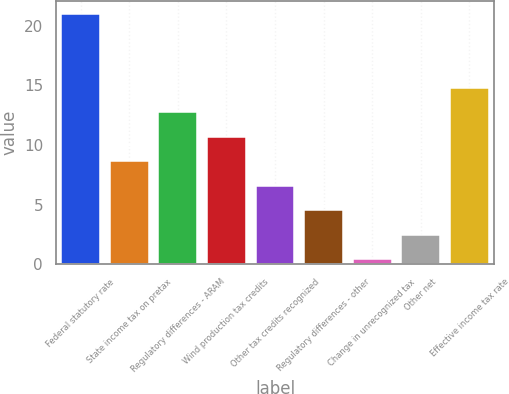<chart> <loc_0><loc_0><loc_500><loc_500><bar_chart><fcel>Federal statutory rate<fcel>State income tax on pretax<fcel>Regulatory differences - ARAM<fcel>Wind production tax credits<fcel>Other tax credits recognized<fcel>Regulatory differences - other<fcel>Change in unrecognized tax<fcel>Other net<fcel>Effective income tax rate<nl><fcel>21<fcel>8.64<fcel>12.76<fcel>10.7<fcel>6.58<fcel>4.52<fcel>0.4<fcel>2.46<fcel>14.82<nl></chart> 